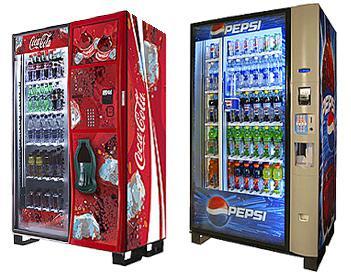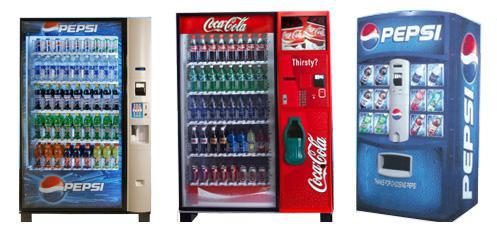The first image is the image on the left, the second image is the image on the right. For the images displayed, is the sentence "There are more machines in the image on the right than in the image on the left." factually correct? Answer yes or no. Yes. The first image is the image on the left, the second image is the image on the right. Assess this claim about the two images: "Each image prominently features exactly one vending machine, which is blue.". Correct or not? Answer yes or no. No. 